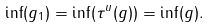Convert formula to latex. <formula><loc_0><loc_0><loc_500><loc_500>\inf ( g _ { 1 } ) = \inf ( \tau ^ { u } ( g ) ) = \inf ( g ) .</formula> 